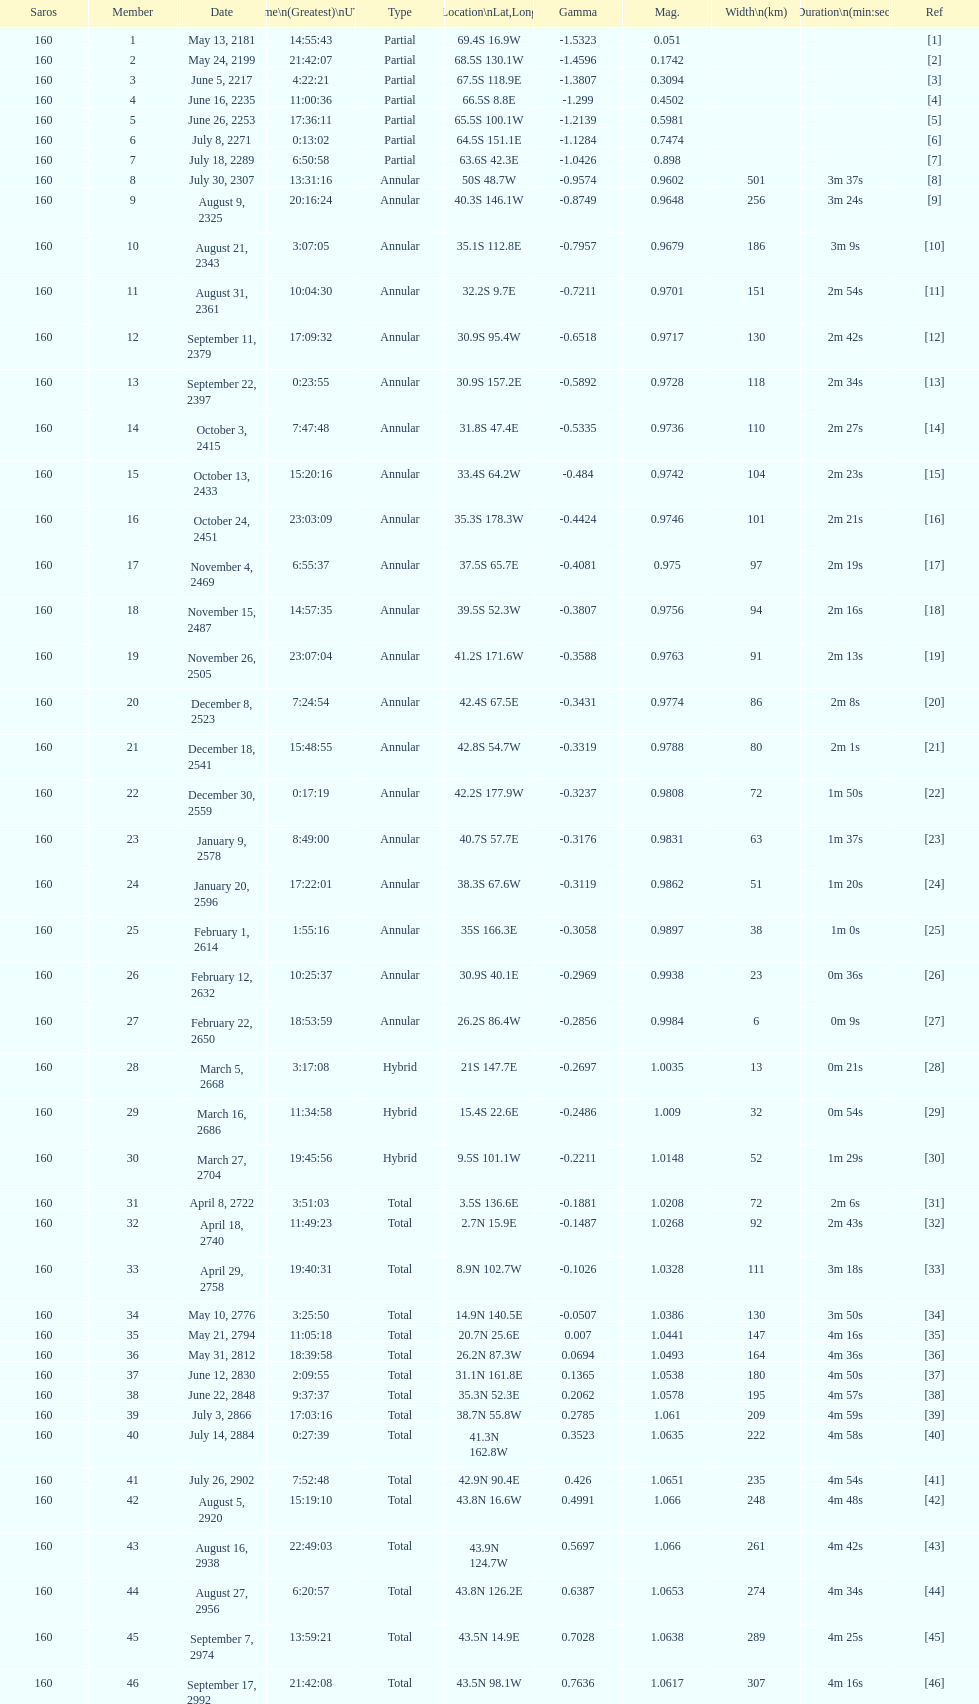00? March 5, 2668. 